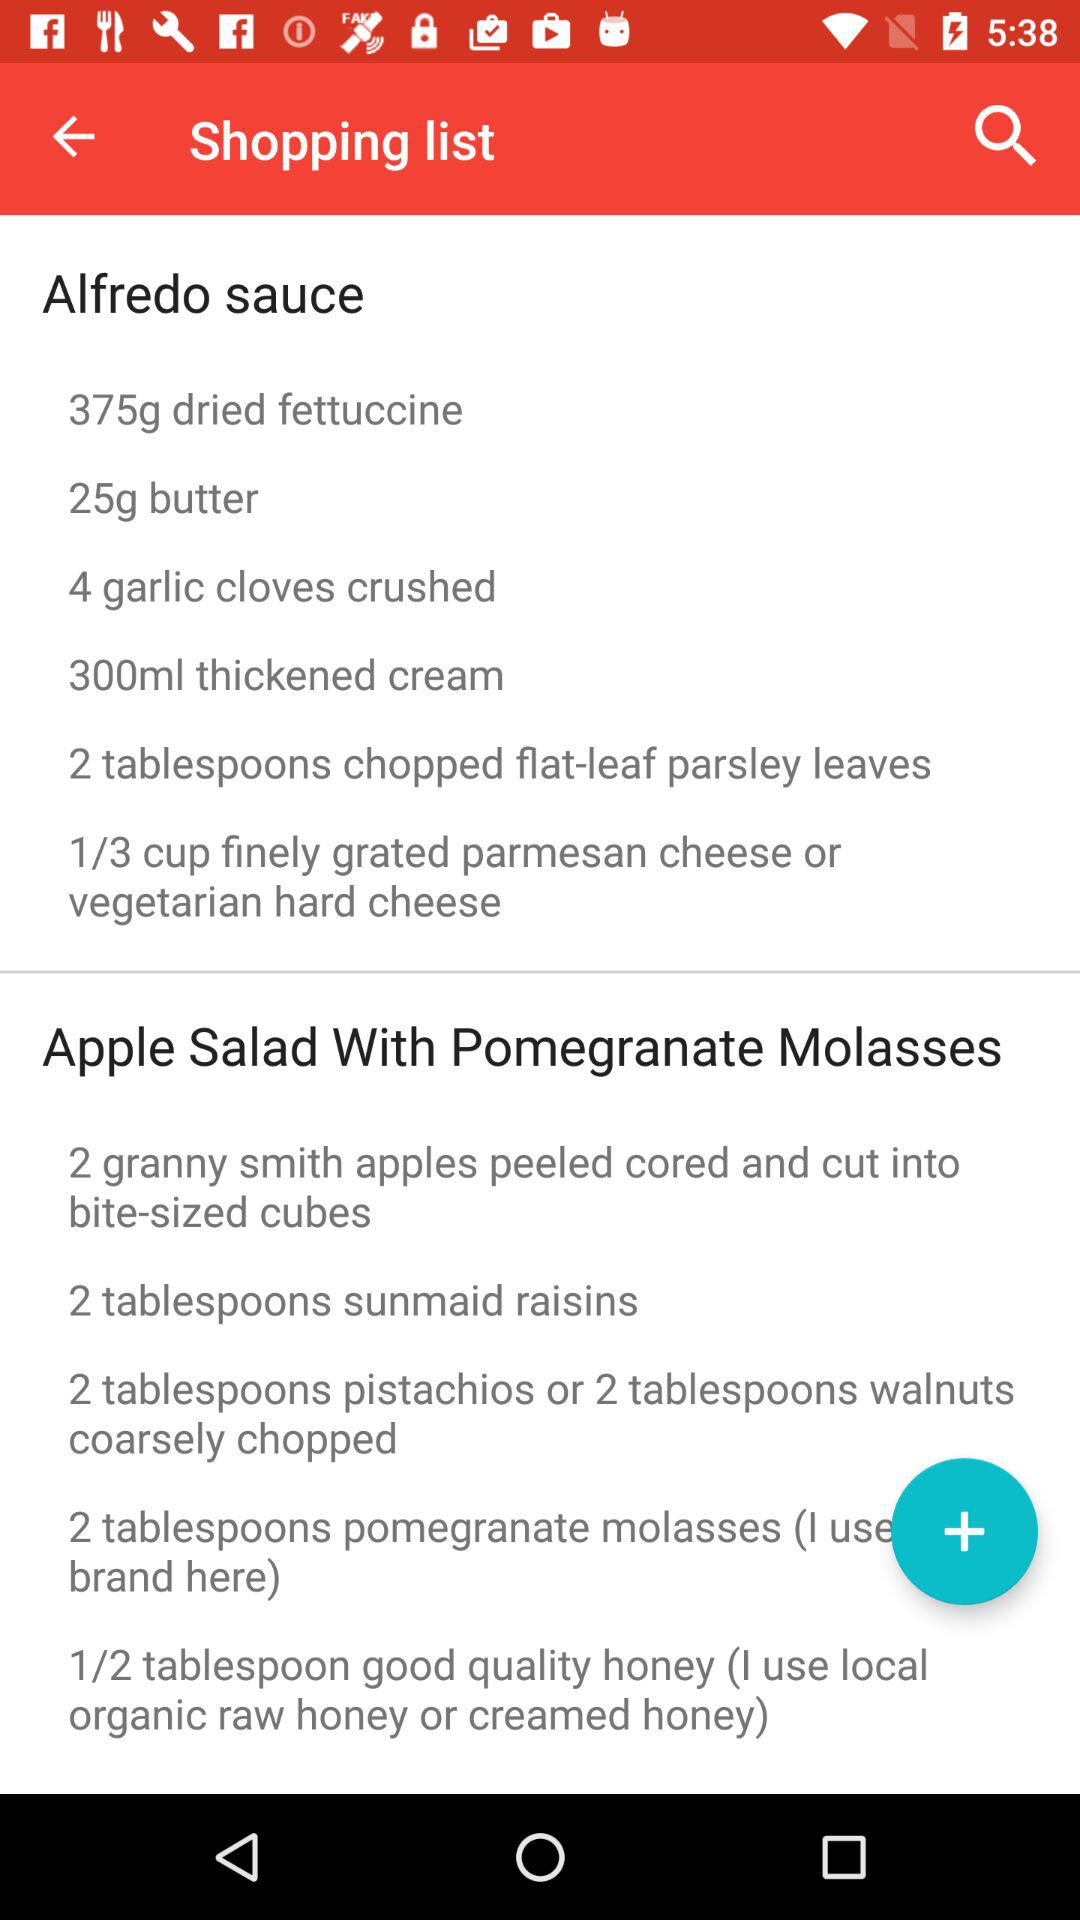How long does it take to prepare the Alfredo sauce?
When the provided information is insufficient, respond with <no answer>. <no answer> 